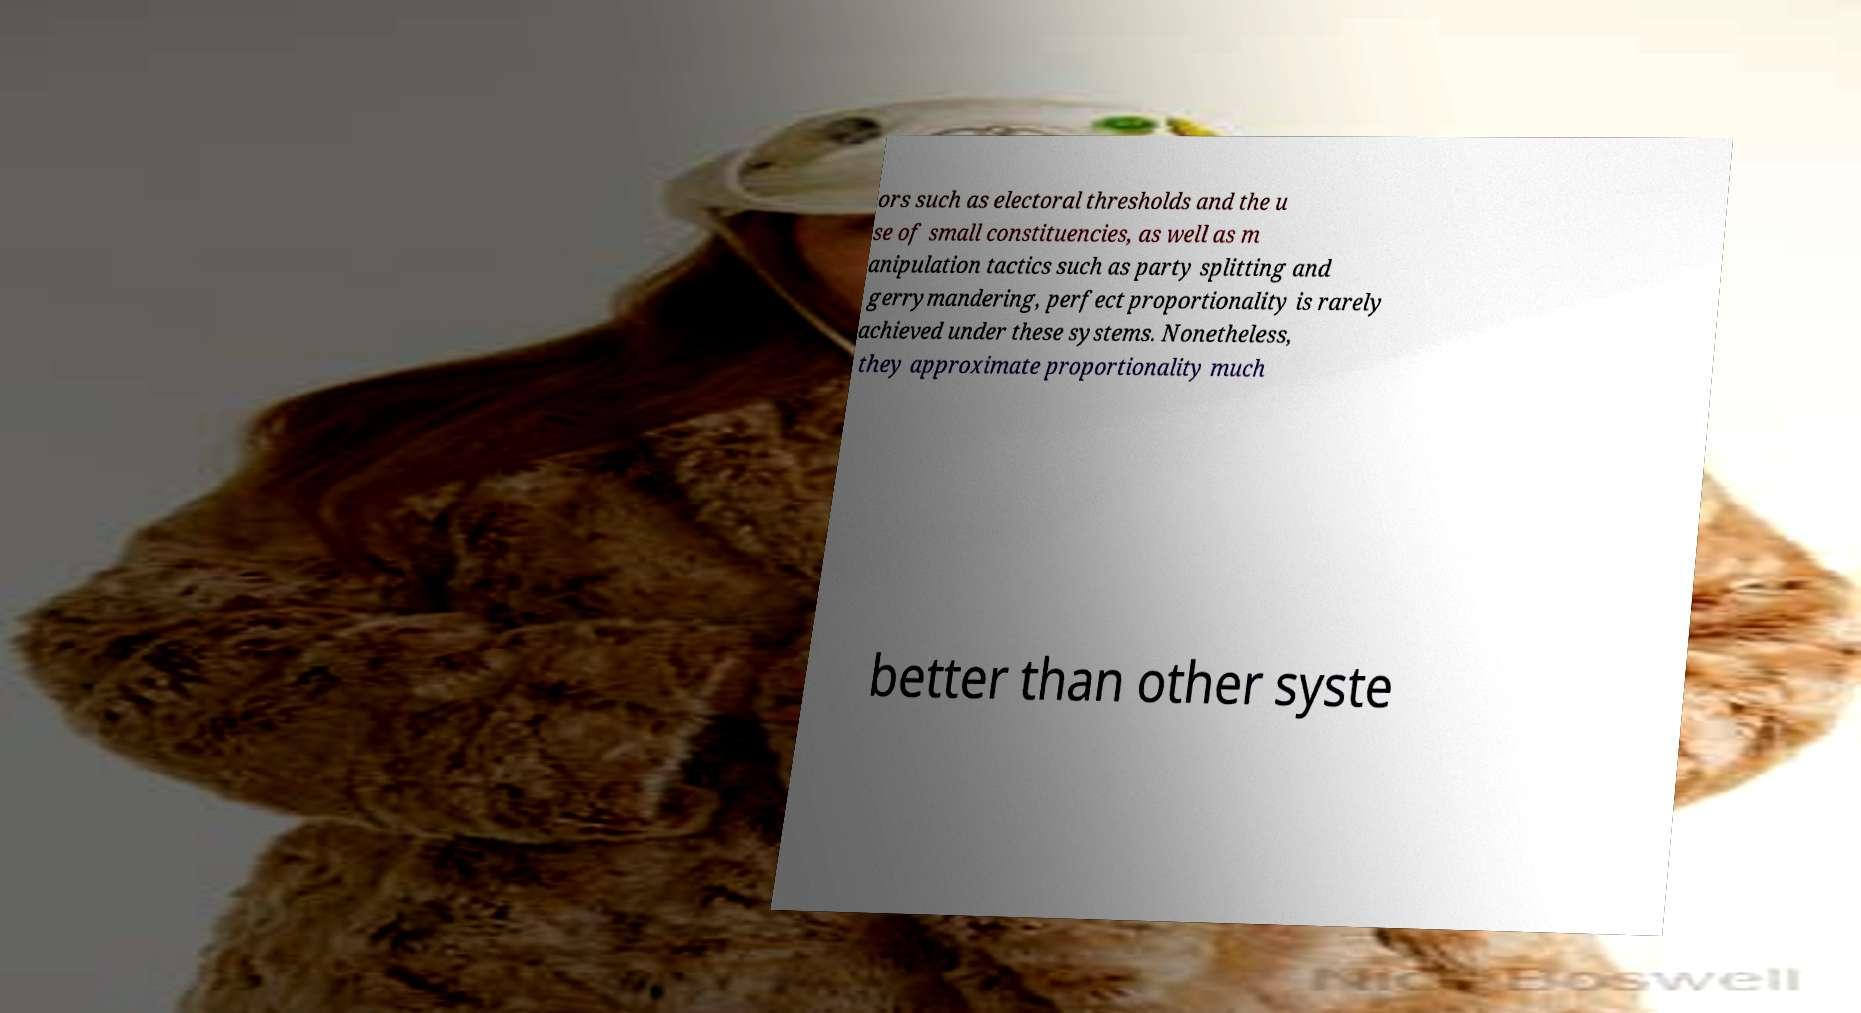Could you assist in decoding the text presented in this image and type it out clearly? ors such as electoral thresholds and the u se of small constituencies, as well as m anipulation tactics such as party splitting and gerrymandering, perfect proportionality is rarely achieved under these systems. Nonetheless, they approximate proportionality much better than other syste 